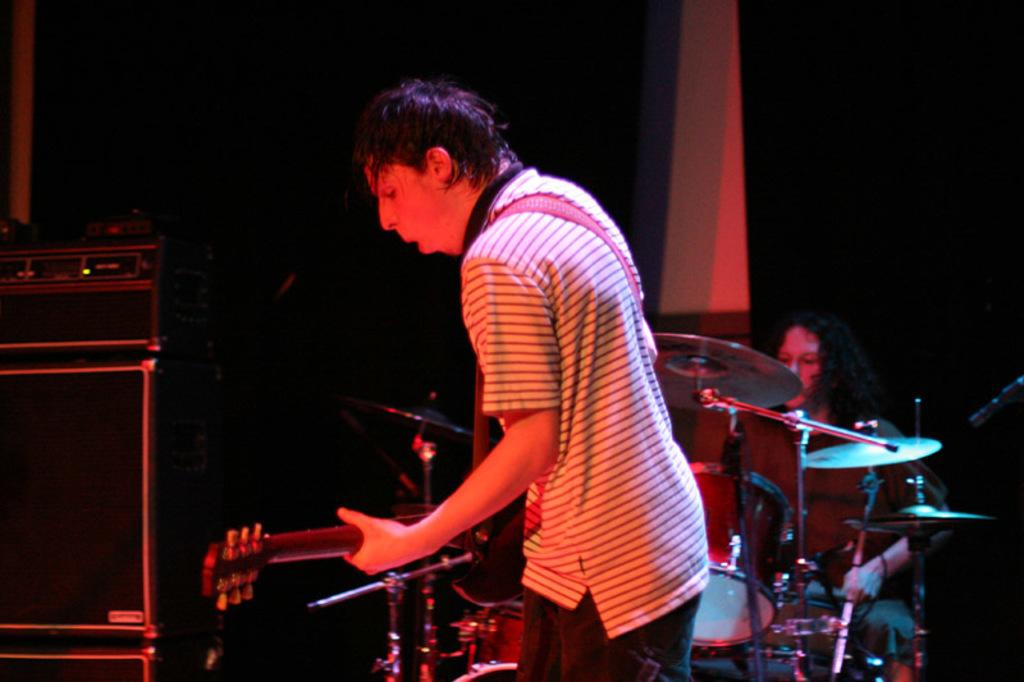How many people are in the image? There are two people in the image. What are the people in the image doing? Both people are playing musical instruments. What type of whip is being used by one of the people in the image? There is no whip present in the image; both people are playing musical instruments. What direction are the people pointing in the image? The image does not show the people pointing in any specific direction; they are focused on playing their musical instruments. 